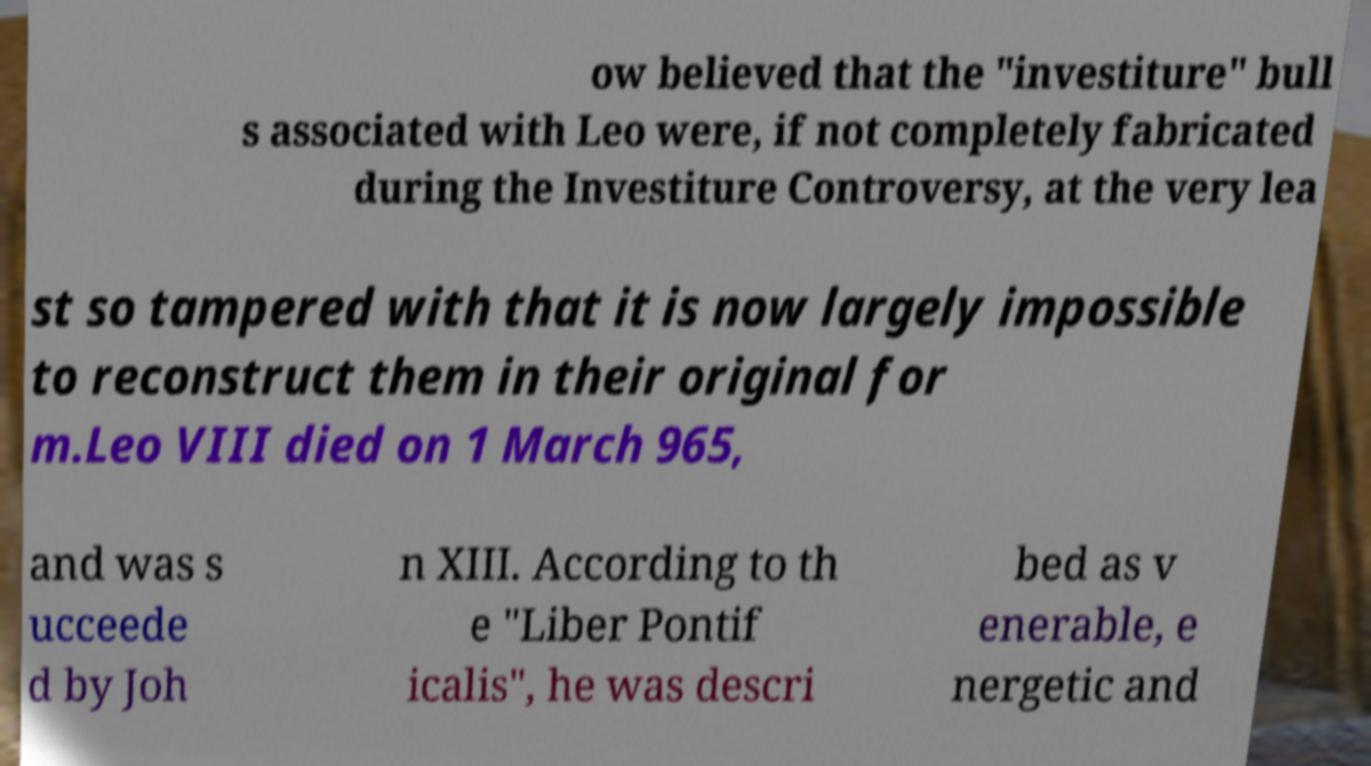Please read and relay the text visible in this image. What does it say? ow believed that the "investiture" bull s associated with Leo were, if not completely fabricated during the Investiture Controversy, at the very lea st so tampered with that it is now largely impossible to reconstruct them in their original for m.Leo VIII died on 1 March 965, and was s ucceede d by Joh n XIII. According to th e "Liber Pontif icalis", he was descri bed as v enerable, e nergetic and 